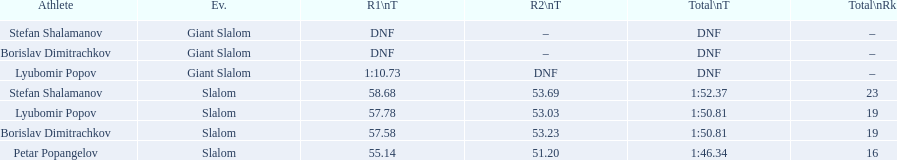How long did it take for lyubomir popov to finish the giant slalom in race 1? 1:10.73. 